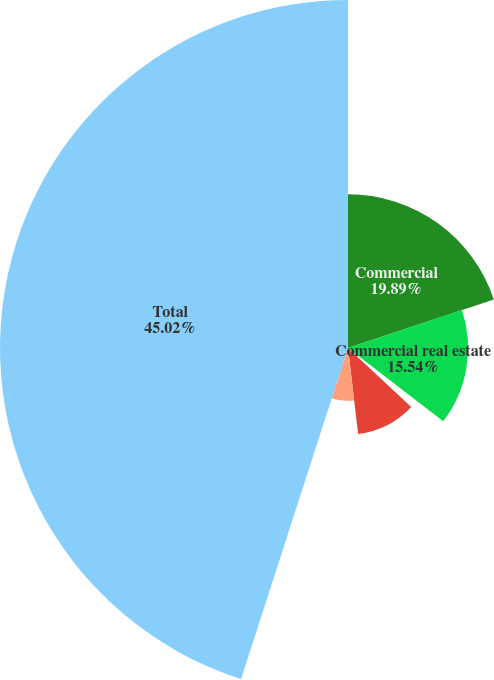Convert chart. <chart><loc_0><loc_0><loc_500><loc_500><pie_chart><fcel>Commercial<fcel>Commercial real estate<fcel>Equipment lease financing<fcel>Consumer (a)<fcel>Residential real estate<fcel>Total<nl><fcel>19.89%<fcel>15.54%<fcel>1.52%<fcel>11.19%<fcel>6.84%<fcel>45.03%<nl></chart> 